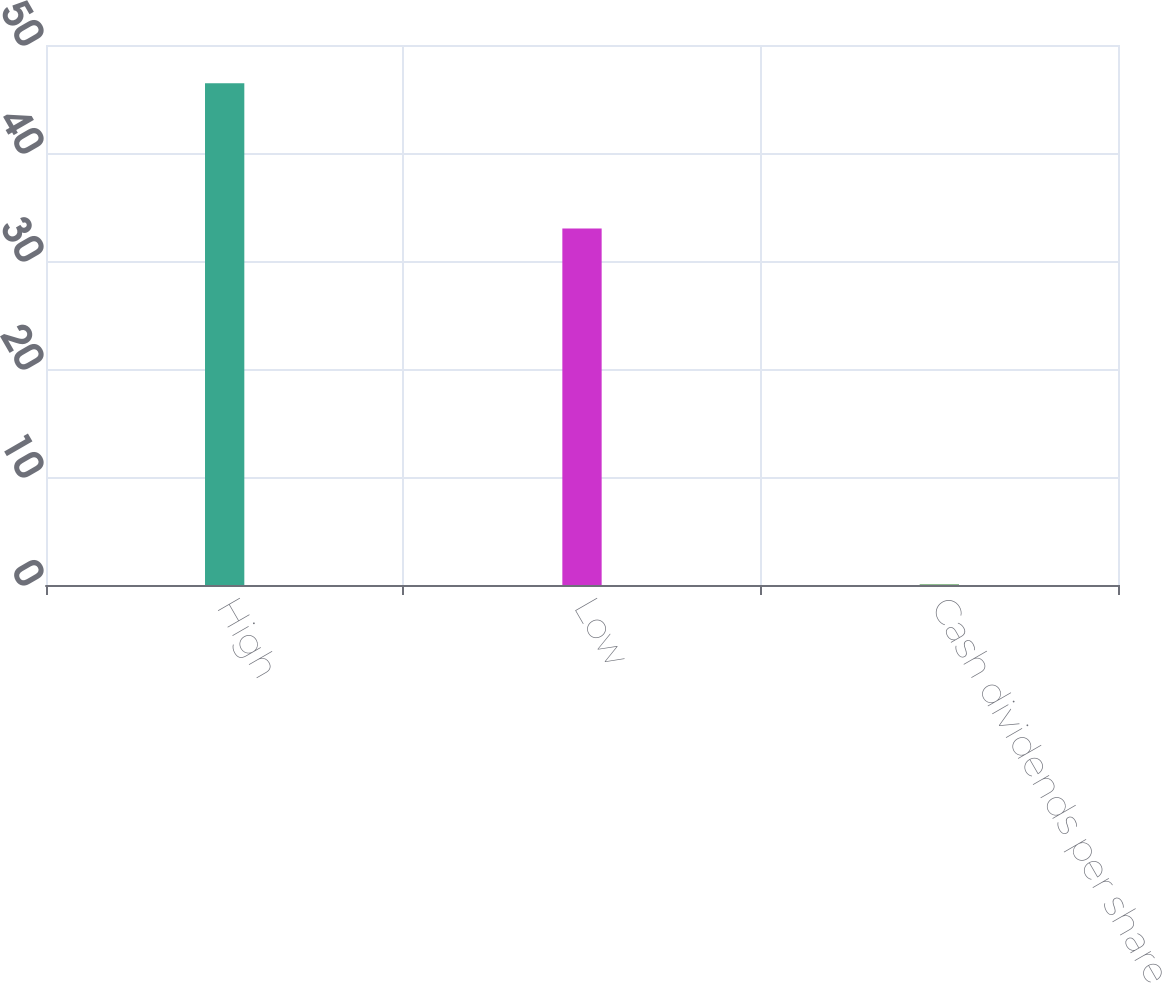Convert chart. <chart><loc_0><loc_0><loc_500><loc_500><bar_chart><fcel>High<fcel>Low<fcel>Cash dividends per share<nl><fcel>46.45<fcel>33.02<fcel>0.1<nl></chart> 